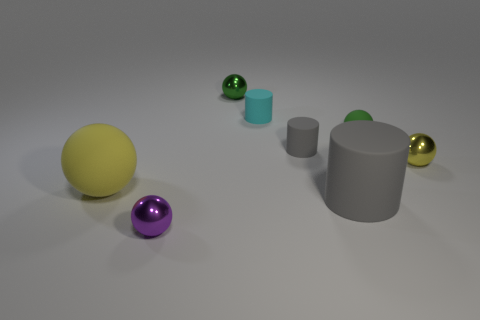Is there a small green sphere?
Offer a terse response. Yes. The green thing that is on the left side of the tiny rubber cylinder in front of the small green rubber object is what shape?
Provide a short and direct response. Sphere. How many objects are either green rubber things or matte objects that are left of the purple ball?
Offer a terse response. 2. There is a small shiny thing in front of the small sphere on the right side of the green sphere right of the small cyan rubber object; what is its color?
Provide a short and direct response. Purple. What is the material of the tiny purple thing that is the same shape as the small yellow metallic object?
Your answer should be compact. Metal. What color is the tiny matte ball?
Provide a succinct answer. Green. How many metallic things are small green objects or small yellow balls?
Offer a terse response. 2. Are there any green objects that are to the left of the small metal object that is to the right of the matte cylinder that is on the right side of the small gray matte cylinder?
Offer a terse response. Yes. There is a cyan object that is the same material as the tiny gray thing; what is its size?
Offer a very short reply. Small. There is a yellow metal object; are there any green metallic balls on the left side of it?
Your response must be concise. Yes. 